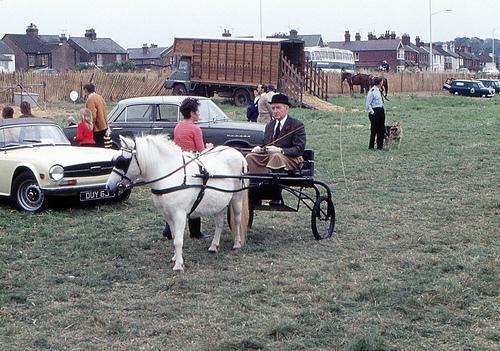How many white ponies are there?
Give a very brief answer. 1. How many people are sitting in a buggy?
Give a very brief answer. 1. 